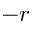Convert formula to latex. <formula><loc_0><loc_0><loc_500><loc_500>- r</formula> 